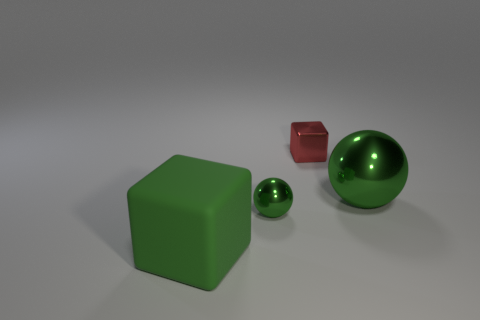There is a big ball that is the same material as the red thing; what color is it?
Give a very brief answer. Green. Is the number of tiny red metallic things less than the number of small red cylinders?
Your answer should be compact. No. What material is the large green thing in front of the big green thing behind the big green block on the left side of the small cube made of?
Your response must be concise. Rubber. What material is the green cube?
Provide a succinct answer. Rubber. There is a big object behind the large green matte thing; is it the same color as the small thing that is in front of the large metallic thing?
Provide a short and direct response. Yes. Is the number of blocks greater than the number of tiny spheres?
Give a very brief answer. Yes. How many large metallic blocks are the same color as the small sphere?
Keep it short and to the point. 0. What is the color of the small metallic thing that is the same shape as the large metallic object?
Provide a succinct answer. Green. What is the material of the green object that is right of the big cube and in front of the large green metallic object?
Give a very brief answer. Metal. Does the tiny object that is in front of the red metallic object have the same material as the thing that is to the right of the red block?
Provide a short and direct response. Yes. 